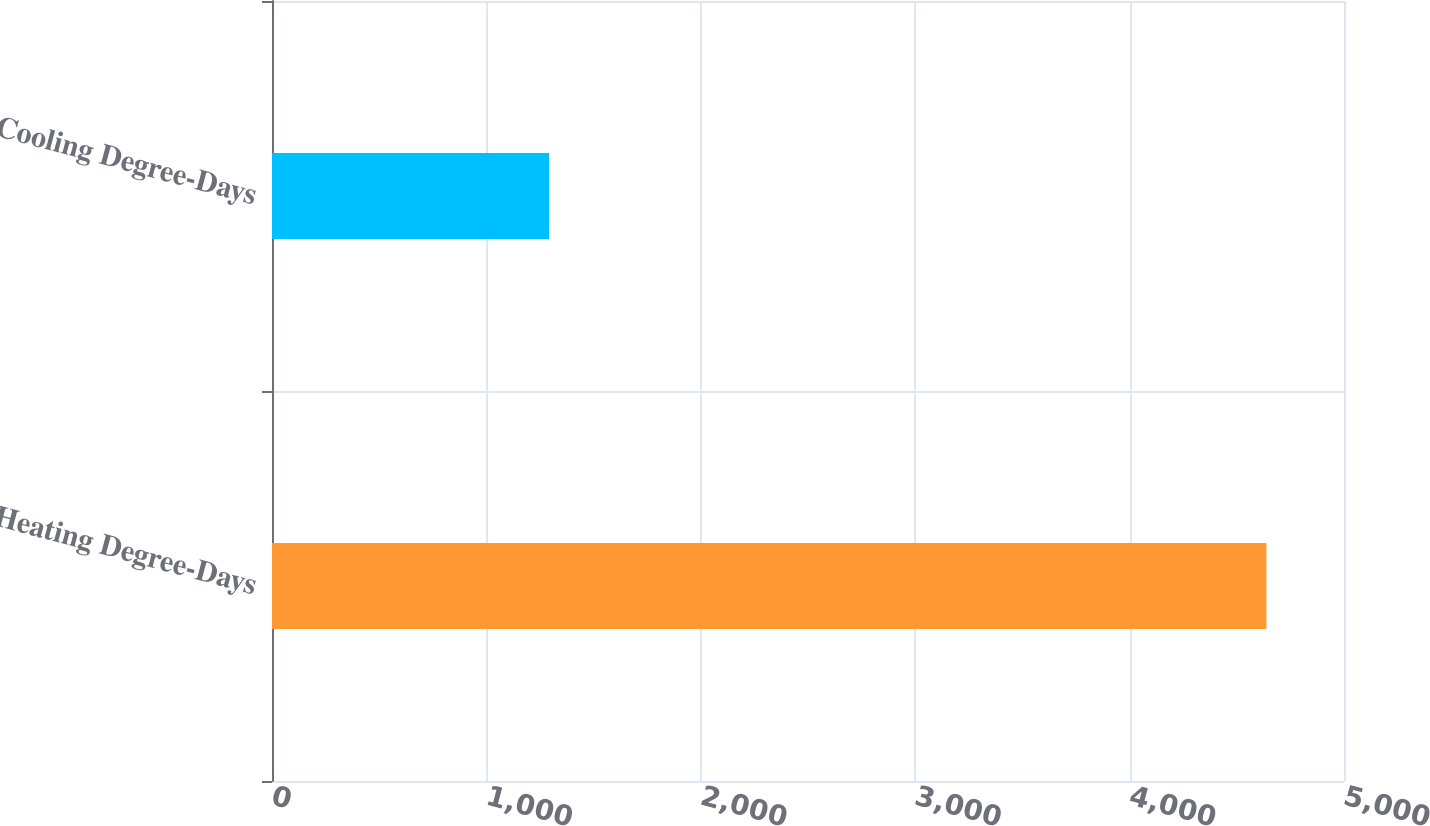Convert chart. <chart><loc_0><loc_0><loc_500><loc_500><bar_chart><fcel>Heating Degree-Days<fcel>Cooling Degree-Days<nl><fcel>4638<fcel>1292<nl></chart> 